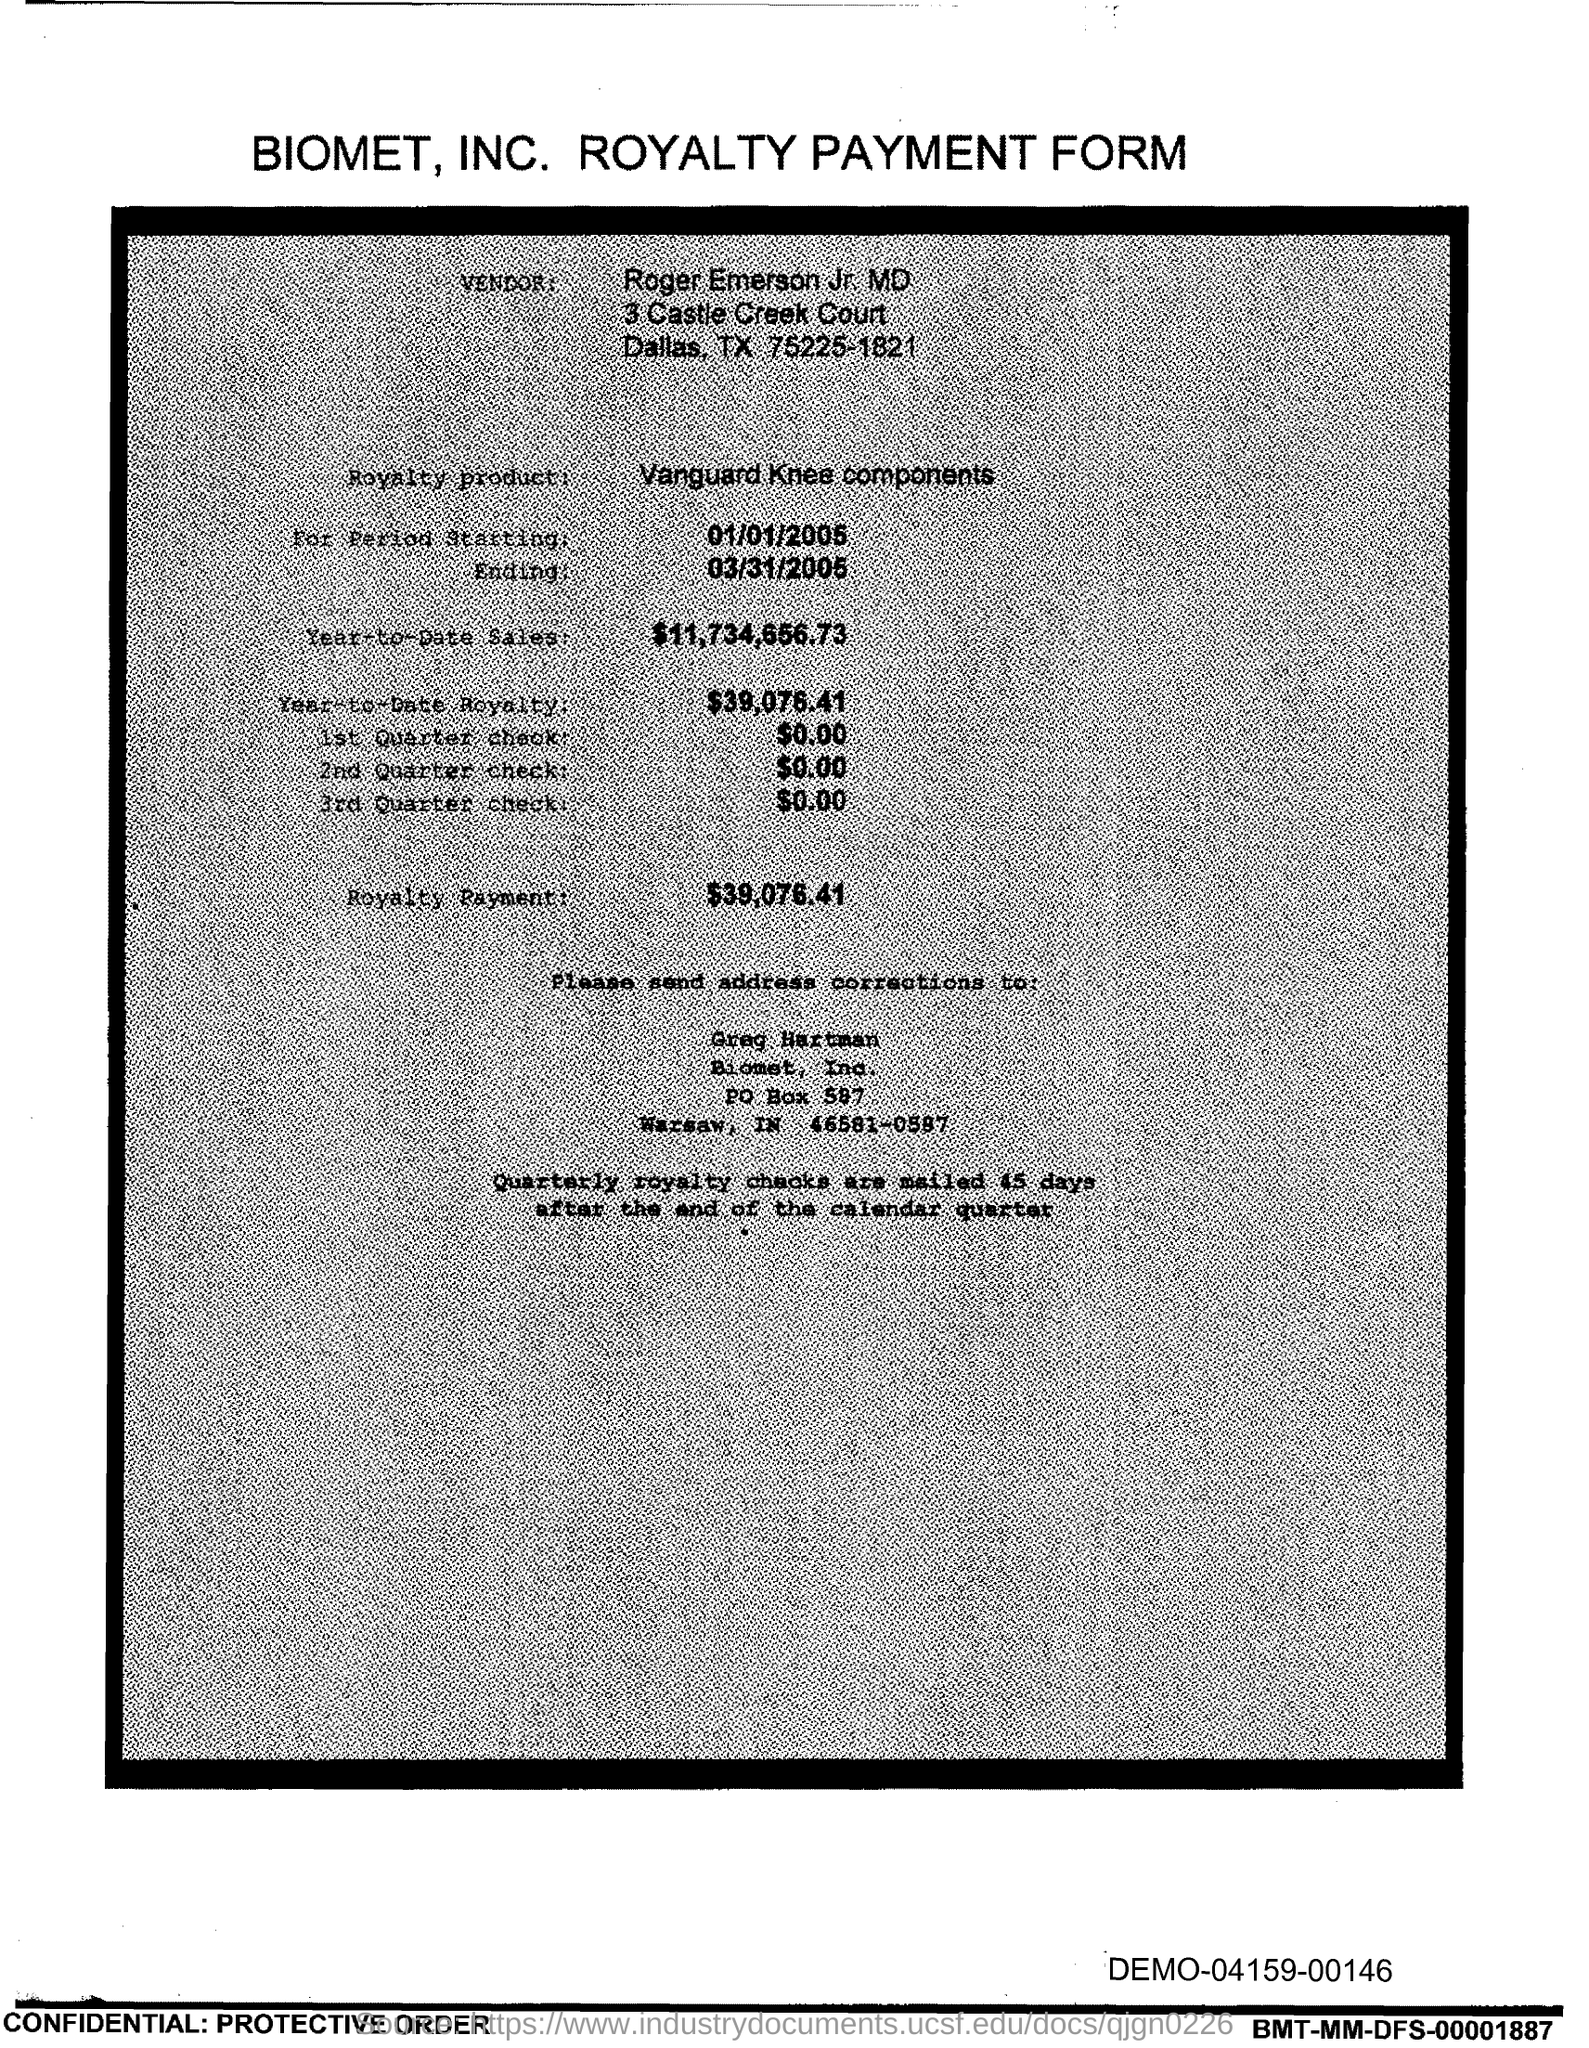Who is the vendor mentioned in the form?
Your answer should be compact. Roger Emerson Jr. MD. What is the royalty product given in the form?
Your answer should be very brief. Vanguard Knee components. What is the start date of the royalty period?
Make the answer very short. 01/01/2005. What is the Year-to-Date Sales of the royalty product?
Your answer should be very brief. 11,734,656.73. What is the Year-to-Date royalty of the product?
Provide a short and direct response. 39,076.41. What is the amount of 1st quarter check mentioned in the form?
Ensure brevity in your answer.  0.00. What is the amount of 2nd Quarter check mentioned in the form?
Provide a succinct answer. 0.00. What is the royalty payment of the product mentioned in the form?
Provide a succinct answer. $39,076.41. What is the end date of the royalty period?
Provide a short and direct response. 03/31/2005. What is the amount of 3rd Quarter check given in the form?
Provide a succinct answer. 0.00. 